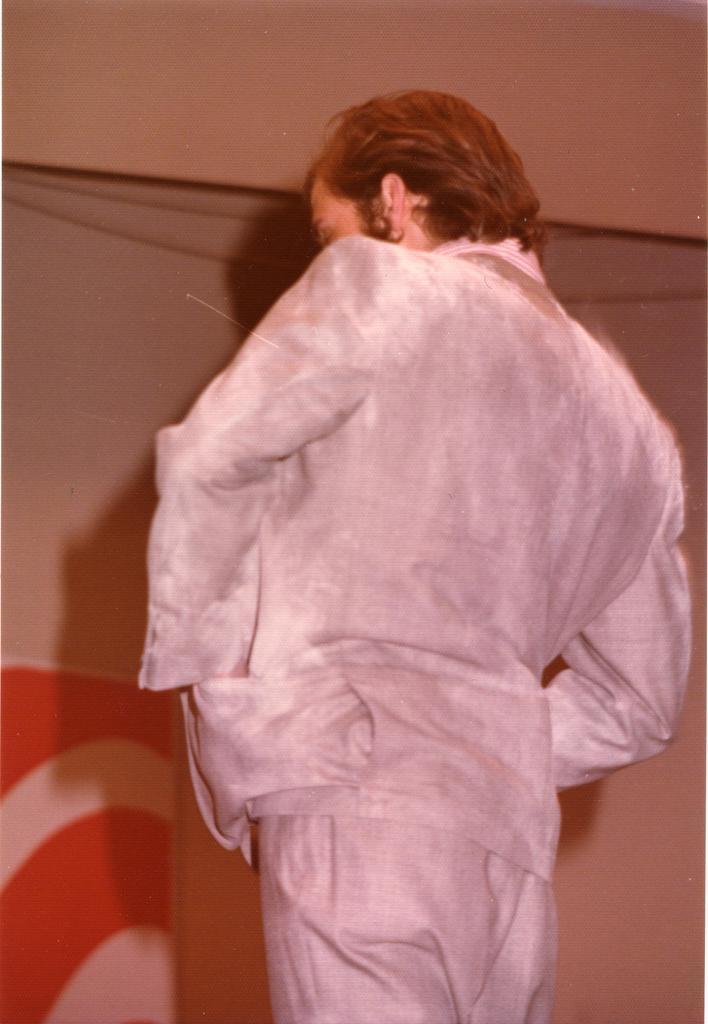Please provide a concise description of this image. In the image there is a man he is standing and behind the man there is some object. 